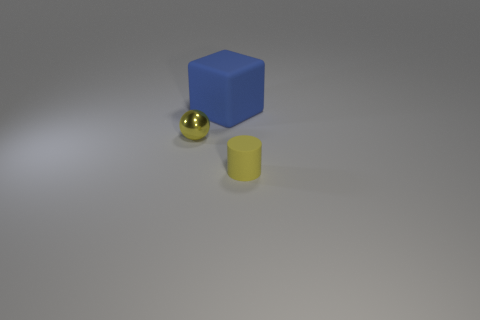Is there anything else that is made of the same material as the yellow sphere?
Offer a terse response. No. Do the matte object left of the yellow cylinder and the ball have the same color?
Offer a very short reply. No. How many other big matte objects have the same shape as the big object?
Offer a very short reply. 0. What number of objects are either small yellow things in front of the small ball or tiny things on the right side of the blue cube?
Offer a terse response. 1. How many blue things are either large metal cubes or rubber blocks?
Ensure brevity in your answer.  1. The object that is both right of the metallic object and in front of the big matte cube is made of what material?
Offer a terse response. Rubber. Does the large object have the same material as the tiny sphere?
Provide a short and direct response. No. How many balls are the same size as the matte cylinder?
Provide a short and direct response. 1. Is the number of blue blocks that are in front of the large blue object the same as the number of large brown blocks?
Your response must be concise. Yes. What number of objects are behind the rubber cylinder and to the right of the metallic thing?
Give a very brief answer. 1. 